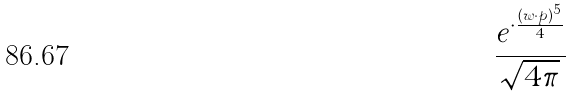Convert formula to latex. <formula><loc_0><loc_0><loc_500><loc_500>\frac { e ^ { \cdot \frac { ( w \cdot p ) ^ { 5 } } { 4 } } } { \sqrt { 4 \pi } }</formula> 